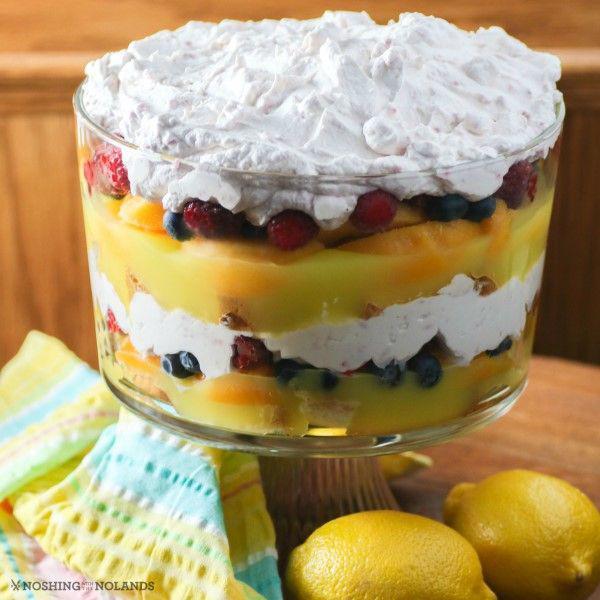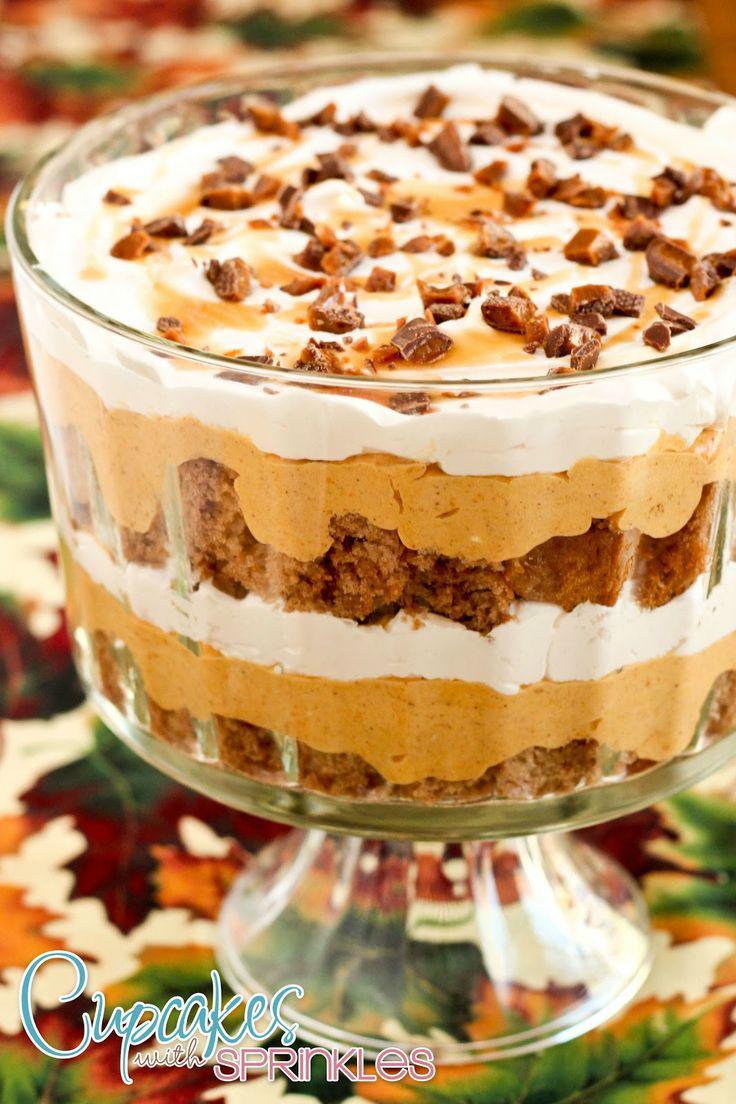The first image is the image on the left, the second image is the image on the right. Assess this claim about the two images: "Two large multi-layered desserts have been prepared in clear glass footed bowls". Correct or not? Answer yes or no. Yes. The first image is the image on the left, the second image is the image on the right. For the images shown, is this caption "An image of a layered dessert in a clear glass includes lemon in the scene." true? Answer yes or no. Yes. 